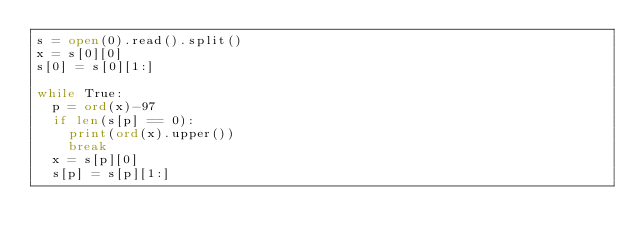<code> <loc_0><loc_0><loc_500><loc_500><_Python_>s = open(0).read().split()
x = s[0][0]
s[0] = s[0][1:]
 
while True:
  p = ord(x)-97
  if len(s[p] == 0):
    print(ord(x).upper())
    break
  x = s[p][0]
  s[p] = s[p][1:]</code> 